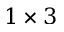Convert formula to latex. <formula><loc_0><loc_0><loc_500><loc_500>1 \times 3</formula> 